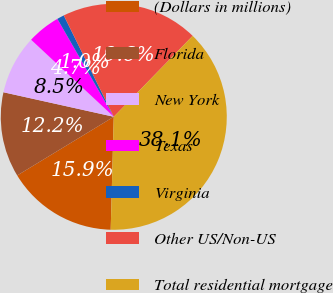Convert chart. <chart><loc_0><loc_0><loc_500><loc_500><pie_chart><fcel>(Dollars in millions)<fcel>Florida<fcel>New York<fcel>Texas<fcel>Virginia<fcel>Other US/Non-US<fcel>Total residential mortgage<nl><fcel>15.88%<fcel>12.17%<fcel>8.46%<fcel>4.74%<fcel>1.03%<fcel>19.59%<fcel>38.14%<nl></chart> 